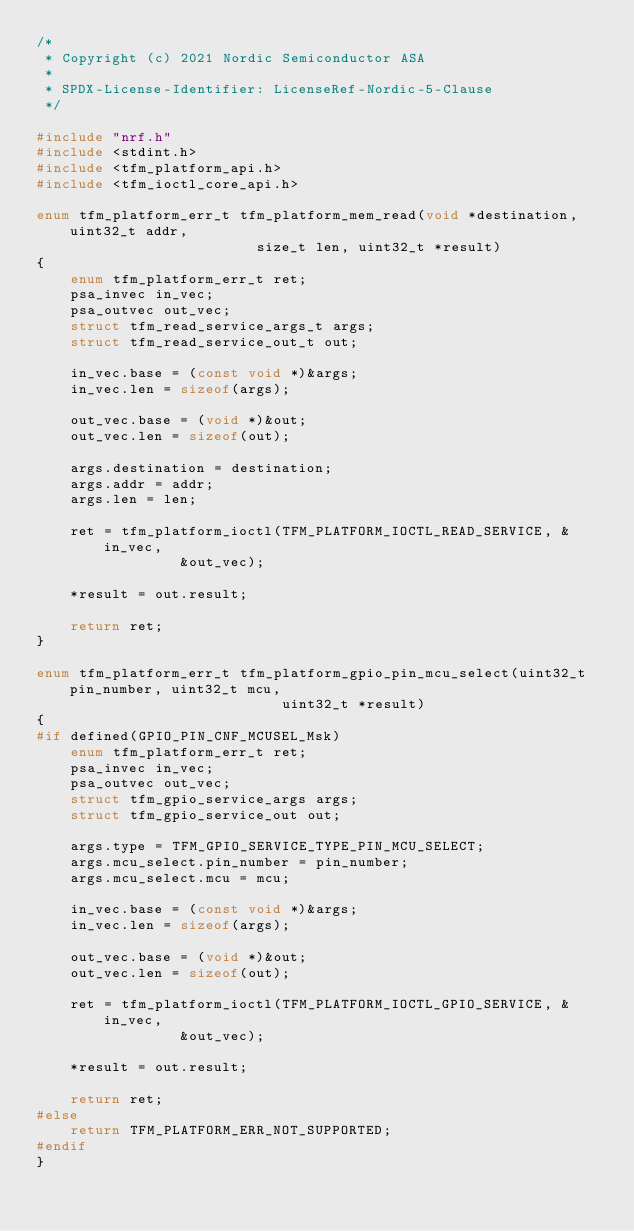Convert code to text. <code><loc_0><loc_0><loc_500><loc_500><_C_>/*
 * Copyright (c) 2021 Nordic Semiconductor ASA
 *
 * SPDX-License-Identifier: LicenseRef-Nordic-5-Clause
 */

#include "nrf.h"
#include <stdint.h>
#include <tfm_platform_api.h>
#include <tfm_ioctl_core_api.h>

enum tfm_platform_err_t tfm_platform_mem_read(void *destination, uint32_t addr,
					      size_t len, uint32_t *result)
{
	enum tfm_platform_err_t ret;
	psa_invec in_vec;
	psa_outvec out_vec;
	struct tfm_read_service_args_t args;
	struct tfm_read_service_out_t out;

	in_vec.base = (const void *)&args;
	in_vec.len = sizeof(args);

	out_vec.base = (void *)&out;
	out_vec.len = sizeof(out);

	args.destination = destination;
	args.addr = addr;
	args.len = len;

	ret = tfm_platform_ioctl(TFM_PLATFORM_IOCTL_READ_SERVICE, &in_vec,
				 &out_vec);

	*result = out.result;

	return ret;
}

enum tfm_platform_err_t tfm_platform_gpio_pin_mcu_select(uint32_t pin_number, uint32_t mcu,
							 uint32_t *result)
{
#if defined(GPIO_PIN_CNF_MCUSEL_Msk)
	enum tfm_platform_err_t ret;
	psa_invec in_vec;
	psa_outvec out_vec;
	struct tfm_gpio_service_args args;
	struct tfm_gpio_service_out out;

	args.type = TFM_GPIO_SERVICE_TYPE_PIN_MCU_SELECT;
	args.mcu_select.pin_number = pin_number;
	args.mcu_select.mcu = mcu;

	in_vec.base = (const void *)&args;
	in_vec.len = sizeof(args);

	out_vec.base = (void *)&out;
	out_vec.len = sizeof(out);

	ret = tfm_platform_ioctl(TFM_PLATFORM_IOCTL_GPIO_SERVICE, &in_vec,
				 &out_vec);

	*result = out.result;

	return ret;
#else
	return TFM_PLATFORM_ERR_NOT_SUPPORTED;
#endif
}
</code> 